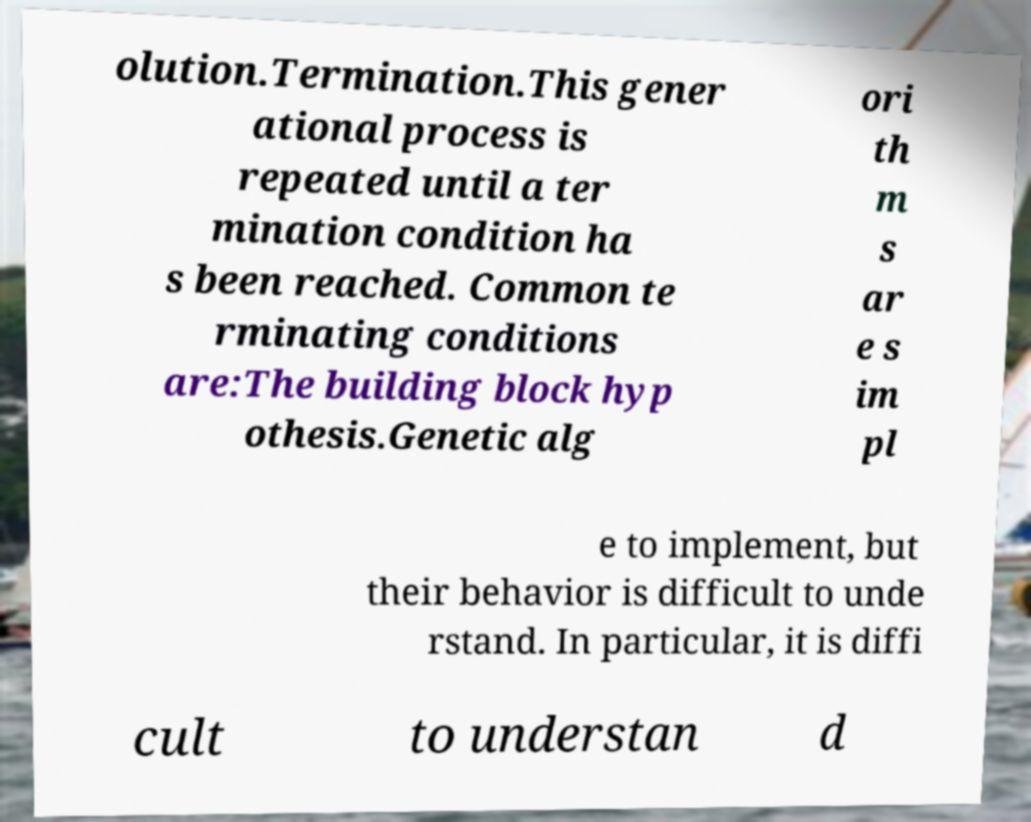Could you assist in decoding the text presented in this image and type it out clearly? olution.Termination.This gener ational process is repeated until a ter mination condition ha s been reached. Common te rminating conditions are:The building block hyp othesis.Genetic alg ori th m s ar e s im pl e to implement, but their behavior is difficult to unde rstand. In particular, it is diffi cult to understan d 